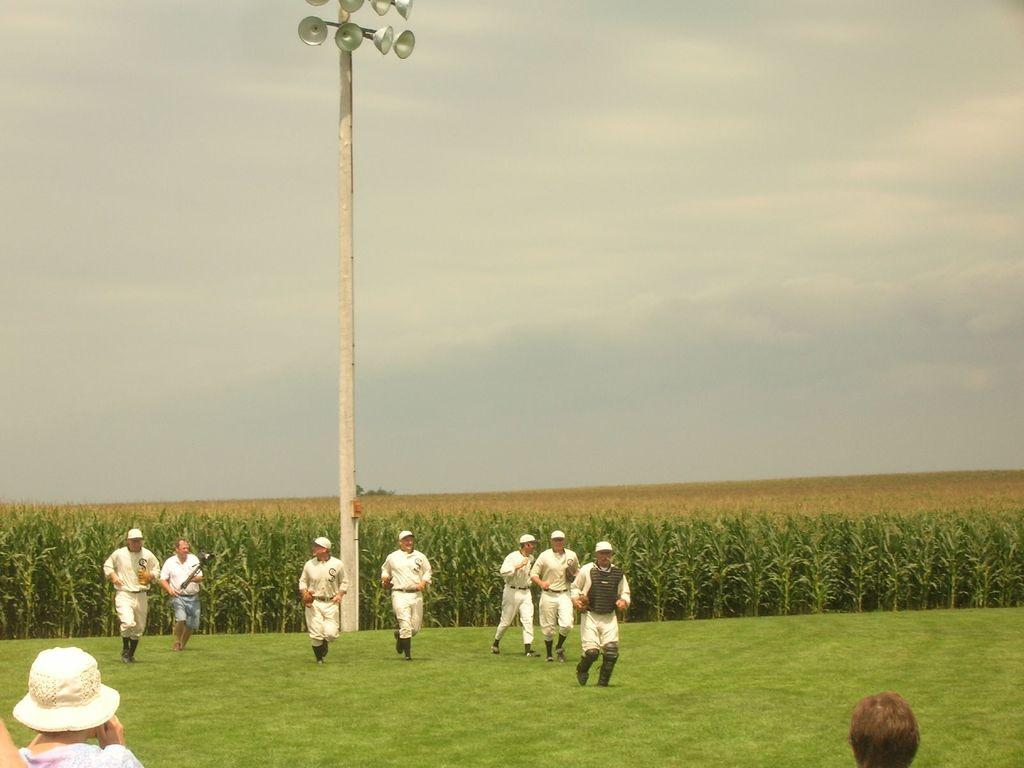What is the surface that the persons are standing on in the image? There is grass visible in the image, and the persons are standing on it. What type of area is depicted in the image? There is a field in the image. What is the pole used for in the image? The pole is likely used to support the lights, which are also visible in the image. What can be seen in the background of the image? The sky is visible in the background of the image. What type of oranges are hanging from the pole in the image? There are no oranges present in the image; the pole is supporting lights. Can you describe the person standing near the pole in the image? There is no specific person mentioned in the provided facts, so we cannot describe any person standing near the pole. 